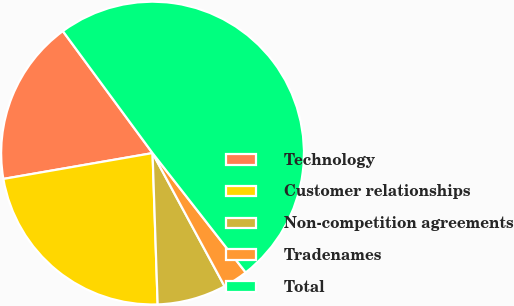Convert chart. <chart><loc_0><loc_0><loc_500><loc_500><pie_chart><fcel>Technology<fcel>Customer relationships<fcel>Non-competition agreements<fcel>Tradenames<fcel>Total<nl><fcel>17.64%<fcel>22.81%<fcel>7.35%<fcel>2.66%<fcel>49.55%<nl></chart> 